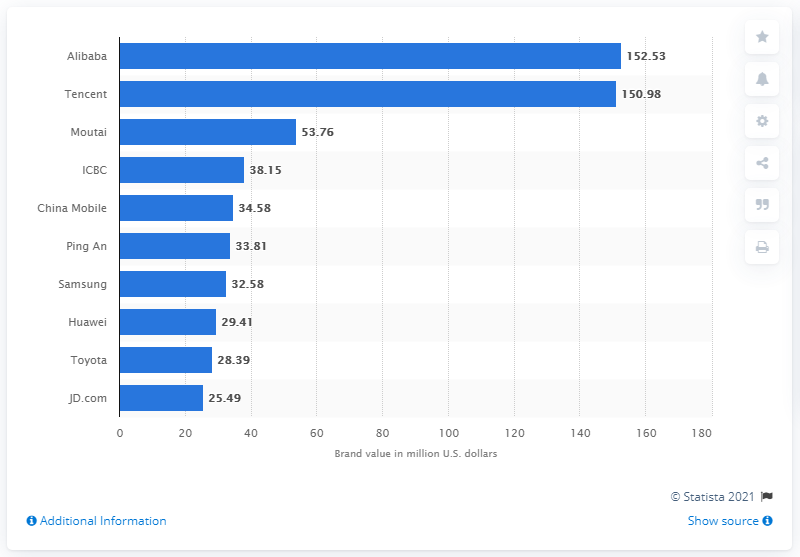Outline some significant characteristics in this image. Alibaba is the most valuable brand in Asia. Alibaba was slightly ahead of Tencent in value in 2020, with Tencent being their main competitor. Moutai was the top riser in this year's ranking. 